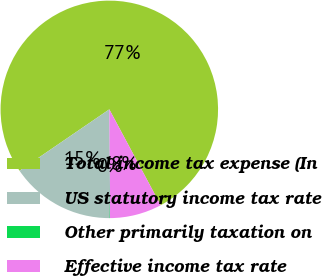<chart> <loc_0><loc_0><loc_500><loc_500><pie_chart><fcel>Total income tax expense (In<fcel>US statutory income tax rate<fcel>Other primarily taxation on<fcel>Effective income tax rate<nl><fcel>76.71%<fcel>15.42%<fcel>0.1%<fcel>7.76%<nl></chart> 